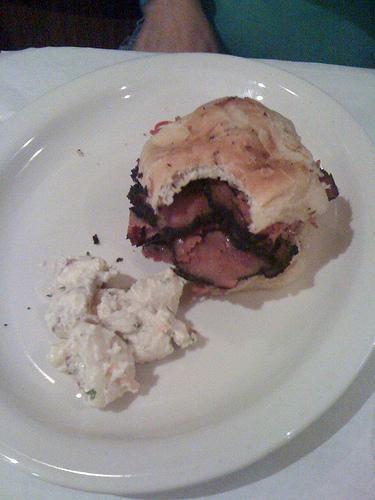How many people are in the photo?
Give a very brief answer. 1. 